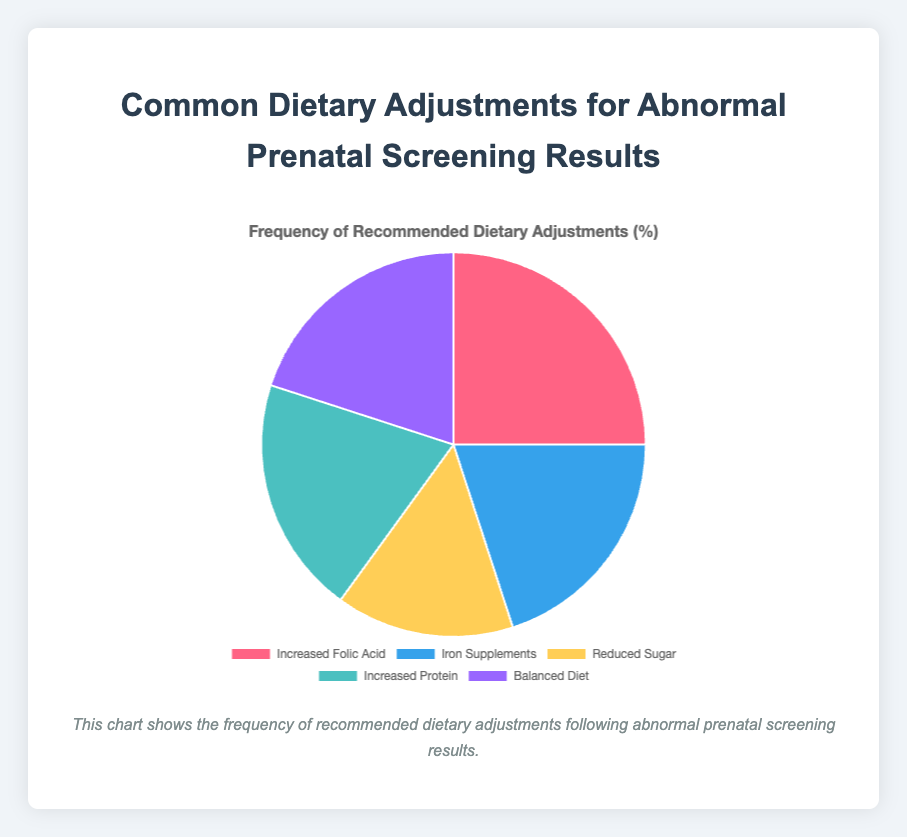What's the most common dietary adjustment recommended for abnormal prenatal screening results? The pie chart shows 'Increased Folic Acid' occupies the largest portion.
Answer: Increased Folic Acid Which dietary adjustments have the same recommended frequency? The pie chart shows that 'Iron Supplements', 'Increased Protein', and 'Balanced Diet' each occupy 20%.
Answer: Iron Supplements, Increased Protein, and Balanced Diet What is the total percentage of people recommended to adjust their protein intake, either increased or reduced? Only 'Increased Protein' is related to protein adjustment, which is 20%.
Answer: 20% How much less common is 'Reduced Sugar' compared to 'Increased Folic Acid'? 'Increased Folic Acid' is 25%, and 'Reduced Sugar' is 15%. The difference is 25% - 15% = 10%.
Answer: 10% What is the combined percentage of recommendations for 'Iron Supplements' and 'Reduced Sugar'? 'Iron Supplements' is 20%, and 'Reduced Sugar' is 15%. The combined percentage is 20% + 15% = 35%.
Answer: 35% Which segment is represented by the yellow color? The pie chart uses descriptions for each color, and 'Reduced Sugar' is represented by yellow.
Answer: Reduced Sugar Is the percentage of 'Balanced Diet' adjustments higher, lower, or equal to the 'Increased Protein' recommendations? Both 'Balanced Diet' and 'Increased Protein' have the same portion of 20%.
Answer: Equal What is the average frequency percentage of all dietary adjustments shown? The percentages are 25%, 20%, 15%, 20%, and 20%. The average is (25 + 20 + 15 + 20 + 20) / 5 = 100 / 5.
Answer: 20% 